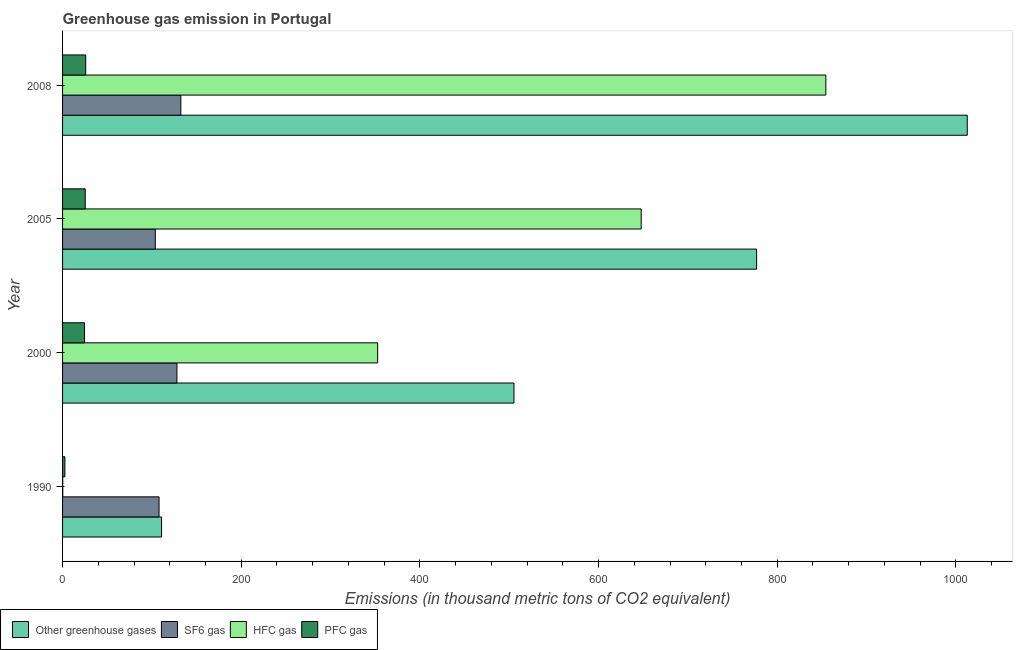How many different coloured bars are there?
Offer a very short reply. 4. Are the number of bars per tick equal to the number of legend labels?
Keep it short and to the point. Yes. Are the number of bars on each tick of the Y-axis equal?
Give a very brief answer. Yes. In how many cases, is the number of bars for a given year not equal to the number of legend labels?
Keep it short and to the point. 0. What is the emission of pfc gas in 1990?
Make the answer very short. 2.6. Across all years, what is the maximum emission of pfc gas?
Provide a short and direct response. 25.9. Across all years, what is the minimum emission of sf6 gas?
Offer a very short reply. 103.8. In which year was the emission of hfc gas minimum?
Your answer should be very brief. 1990. What is the total emission of greenhouse gases in the graph?
Your answer should be compact. 2405.7. What is the difference between the emission of pfc gas in 2005 and that in 2008?
Make the answer very short. -0.5. What is the difference between the emission of sf6 gas in 2000 and the emission of hfc gas in 2008?
Your answer should be compact. -726.4. What is the average emission of hfc gas per year?
Provide a succinct answer. 463.75. In the year 2008, what is the difference between the emission of greenhouse gases and emission of hfc gas?
Provide a succinct answer. 158.3. In how many years, is the emission of sf6 gas greater than 240 thousand metric tons?
Give a very brief answer. 0. What is the ratio of the emission of greenhouse gases in 2000 to that in 2005?
Your answer should be very brief. 0.65. Is the emission of hfc gas in 2000 less than that in 2008?
Offer a terse response. Yes. Is the difference between the emission of greenhouse gases in 1990 and 2005 greater than the difference between the emission of sf6 gas in 1990 and 2005?
Provide a succinct answer. No. What is the difference between the highest and the second highest emission of hfc gas?
Give a very brief answer. 206.7. What is the difference between the highest and the lowest emission of hfc gas?
Your answer should be very brief. 854.2. In how many years, is the emission of sf6 gas greater than the average emission of sf6 gas taken over all years?
Your answer should be compact. 2. Is the sum of the emission of greenhouse gases in 1990 and 2005 greater than the maximum emission of sf6 gas across all years?
Your answer should be very brief. Yes. Is it the case that in every year, the sum of the emission of greenhouse gases and emission of sf6 gas is greater than the sum of emission of hfc gas and emission of pfc gas?
Give a very brief answer. Yes. What does the 2nd bar from the top in 2005 represents?
Keep it short and to the point. HFC gas. What does the 3rd bar from the bottom in 2000 represents?
Offer a very short reply. HFC gas. Is it the case that in every year, the sum of the emission of greenhouse gases and emission of sf6 gas is greater than the emission of hfc gas?
Keep it short and to the point. Yes. Are all the bars in the graph horizontal?
Ensure brevity in your answer.  Yes. How many years are there in the graph?
Offer a very short reply. 4. Are the values on the major ticks of X-axis written in scientific E-notation?
Give a very brief answer. No. Does the graph contain any zero values?
Make the answer very short. No. Does the graph contain grids?
Ensure brevity in your answer.  No. How many legend labels are there?
Give a very brief answer. 4. How are the legend labels stacked?
Make the answer very short. Horizontal. What is the title of the graph?
Offer a very short reply. Greenhouse gas emission in Portugal. Does "Subsidies and Transfers" appear as one of the legend labels in the graph?
Your answer should be compact. No. What is the label or title of the X-axis?
Offer a very short reply. Emissions (in thousand metric tons of CO2 equivalent). What is the label or title of the Y-axis?
Provide a short and direct response. Year. What is the Emissions (in thousand metric tons of CO2 equivalent) of Other greenhouse gases in 1990?
Offer a terse response. 110.8. What is the Emissions (in thousand metric tons of CO2 equivalent) in SF6 gas in 1990?
Ensure brevity in your answer.  108. What is the Emissions (in thousand metric tons of CO2 equivalent) of HFC gas in 1990?
Your response must be concise. 0.2. What is the Emissions (in thousand metric tons of CO2 equivalent) in Other greenhouse gases in 2000?
Your response must be concise. 505.3. What is the Emissions (in thousand metric tons of CO2 equivalent) of SF6 gas in 2000?
Provide a succinct answer. 128. What is the Emissions (in thousand metric tons of CO2 equivalent) of HFC gas in 2000?
Make the answer very short. 352.7. What is the Emissions (in thousand metric tons of CO2 equivalent) in PFC gas in 2000?
Keep it short and to the point. 24.6. What is the Emissions (in thousand metric tons of CO2 equivalent) in Other greenhouse gases in 2005?
Keep it short and to the point. 776.9. What is the Emissions (in thousand metric tons of CO2 equivalent) of SF6 gas in 2005?
Your answer should be very brief. 103.8. What is the Emissions (in thousand metric tons of CO2 equivalent) of HFC gas in 2005?
Offer a terse response. 647.7. What is the Emissions (in thousand metric tons of CO2 equivalent) of PFC gas in 2005?
Your response must be concise. 25.4. What is the Emissions (in thousand metric tons of CO2 equivalent) in Other greenhouse gases in 2008?
Give a very brief answer. 1012.7. What is the Emissions (in thousand metric tons of CO2 equivalent) of SF6 gas in 2008?
Give a very brief answer. 132.4. What is the Emissions (in thousand metric tons of CO2 equivalent) in HFC gas in 2008?
Offer a terse response. 854.4. What is the Emissions (in thousand metric tons of CO2 equivalent) in PFC gas in 2008?
Give a very brief answer. 25.9. Across all years, what is the maximum Emissions (in thousand metric tons of CO2 equivalent) in Other greenhouse gases?
Your answer should be compact. 1012.7. Across all years, what is the maximum Emissions (in thousand metric tons of CO2 equivalent) in SF6 gas?
Your response must be concise. 132.4. Across all years, what is the maximum Emissions (in thousand metric tons of CO2 equivalent) in HFC gas?
Your answer should be compact. 854.4. Across all years, what is the maximum Emissions (in thousand metric tons of CO2 equivalent) of PFC gas?
Your answer should be very brief. 25.9. Across all years, what is the minimum Emissions (in thousand metric tons of CO2 equivalent) of Other greenhouse gases?
Your answer should be compact. 110.8. Across all years, what is the minimum Emissions (in thousand metric tons of CO2 equivalent) in SF6 gas?
Offer a terse response. 103.8. Across all years, what is the minimum Emissions (in thousand metric tons of CO2 equivalent) of PFC gas?
Ensure brevity in your answer.  2.6. What is the total Emissions (in thousand metric tons of CO2 equivalent) of Other greenhouse gases in the graph?
Your answer should be very brief. 2405.7. What is the total Emissions (in thousand metric tons of CO2 equivalent) in SF6 gas in the graph?
Provide a short and direct response. 472.2. What is the total Emissions (in thousand metric tons of CO2 equivalent) of HFC gas in the graph?
Keep it short and to the point. 1855. What is the total Emissions (in thousand metric tons of CO2 equivalent) in PFC gas in the graph?
Provide a short and direct response. 78.5. What is the difference between the Emissions (in thousand metric tons of CO2 equivalent) in Other greenhouse gases in 1990 and that in 2000?
Ensure brevity in your answer.  -394.5. What is the difference between the Emissions (in thousand metric tons of CO2 equivalent) in SF6 gas in 1990 and that in 2000?
Your answer should be compact. -20. What is the difference between the Emissions (in thousand metric tons of CO2 equivalent) of HFC gas in 1990 and that in 2000?
Keep it short and to the point. -352.5. What is the difference between the Emissions (in thousand metric tons of CO2 equivalent) of PFC gas in 1990 and that in 2000?
Offer a very short reply. -22. What is the difference between the Emissions (in thousand metric tons of CO2 equivalent) in Other greenhouse gases in 1990 and that in 2005?
Provide a short and direct response. -666.1. What is the difference between the Emissions (in thousand metric tons of CO2 equivalent) of HFC gas in 1990 and that in 2005?
Your answer should be compact. -647.5. What is the difference between the Emissions (in thousand metric tons of CO2 equivalent) of PFC gas in 1990 and that in 2005?
Give a very brief answer. -22.8. What is the difference between the Emissions (in thousand metric tons of CO2 equivalent) in Other greenhouse gases in 1990 and that in 2008?
Keep it short and to the point. -901.9. What is the difference between the Emissions (in thousand metric tons of CO2 equivalent) of SF6 gas in 1990 and that in 2008?
Your answer should be very brief. -24.4. What is the difference between the Emissions (in thousand metric tons of CO2 equivalent) in HFC gas in 1990 and that in 2008?
Keep it short and to the point. -854.2. What is the difference between the Emissions (in thousand metric tons of CO2 equivalent) of PFC gas in 1990 and that in 2008?
Make the answer very short. -23.3. What is the difference between the Emissions (in thousand metric tons of CO2 equivalent) of Other greenhouse gases in 2000 and that in 2005?
Provide a short and direct response. -271.6. What is the difference between the Emissions (in thousand metric tons of CO2 equivalent) of SF6 gas in 2000 and that in 2005?
Offer a terse response. 24.2. What is the difference between the Emissions (in thousand metric tons of CO2 equivalent) of HFC gas in 2000 and that in 2005?
Keep it short and to the point. -295. What is the difference between the Emissions (in thousand metric tons of CO2 equivalent) in Other greenhouse gases in 2000 and that in 2008?
Your answer should be compact. -507.4. What is the difference between the Emissions (in thousand metric tons of CO2 equivalent) in HFC gas in 2000 and that in 2008?
Provide a succinct answer. -501.7. What is the difference between the Emissions (in thousand metric tons of CO2 equivalent) in PFC gas in 2000 and that in 2008?
Give a very brief answer. -1.3. What is the difference between the Emissions (in thousand metric tons of CO2 equivalent) in Other greenhouse gases in 2005 and that in 2008?
Your answer should be very brief. -235.8. What is the difference between the Emissions (in thousand metric tons of CO2 equivalent) of SF6 gas in 2005 and that in 2008?
Your answer should be very brief. -28.6. What is the difference between the Emissions (in thousand metric tons of CO2 equivalent) of HFC gas in 2005 and that in 2008?
Your answer should be very brief. -206.7. What is the difference between the Emissions (in thousand metric tons of CO2 equivalent) in PFC gas in 2005 and that in 2008?
Offer a very short reply. -0.5. What is the difference between the Emissions (in thousand metric tons of CO2 equivalent) in Other greenhouse gases in 1990 and the Emissions (in thousand metric tons of CO2 equivalent) in SF6 gas in 2000?
Offer a terse response. -17.2. What is the difference between the Emissions (in thousand metric tons of CO2 equivalent) of Other greenhouse gases in 1990 and the Emissions (in thousand metric tons of CO2 equivalent) of HFC gas in 2000?
Make the answer very short. -241.9. What is the difference between the Emissions (in thousand metric tons of CO2 equivalent) of Other greenhouse gases in 1990 and the Emissions (in thousand metric tons of CO2 equivalent) of PFC gas in 2000?
Your response must be concise. 86.2. What is the difference between the Emissions (in thousand metric tons of CO2 equivalent) of SF6 gas in 1990 and the Emissions (in thousand metric tons of CO2 equivalent) of HFC gas in 2000?
Offer a very short reply. -244.7. What is the difference between the Emissions (in thousand metric tons of CO2 equivalent) in SF6 gas in 1990 and the Emissions (in thousand metric tons of CO2 equivalent) in PFC gas in 2000?
Ensure brevity in your answer.  83.4. What is the difference between the Emissions (in thousand metric tons of CO2 equivalent) in HFC gas in 1990 and the Emissions (in thousand metric tons of CO2 equivalent) in PFC gas in 2000?
Offer a terse response. -24.4. What is the difference between the Emissions (in thousand metric tons of CO2 equivalent) of Other greenhouse gases in 1990 and the Emissions (in thousand metric tons of CO2 equivalent) of SF6 gas in 2005?
Offer a very short reply. 7. What is the difference between the Emissions (in thousand metric tons of CO2 equivalent) of Other greenhouse gases in 1990 and the Emissions (in thousand metric tons of CO2 equivalent) of HFC gas in 2005?
Ensure brevity in your answer.  -536.9. What is the difference between the Emissions (in thousand metric tons of CO2 equivalent) in Other greenhouse gases in 1990 and the Emissions (in thousand metric tons of CO2 equivalent) in PFC gas in 2005?
Your response must be concise. 85.4. What is the difference between the Emissions (in thousand metric tons of CO2 equivalent) in SF6 gas in 1990 and the Emissions (in thousand metric tons of CO2 equivalent) in HFC gas in 2005?
Give a very brief answer. -539.7. What is the difference between the Emissions (in thousand metric tons of CO2 equivalent) of SF6 gas in 1990 and the Emissions (in thousand metric tons of CO2 equivalent) of PFC gas in 2005?
Provide a succinct answer. 82.6. What is the difference between the Emissions (in thousand metric tons of CO2 equivalent) in HFC gas in 1990 and the Emissions (in thousand metric tons of CO2 equivalent) in PFC gas in 2005?
Your answer should be compact. -25.2. What is the difference between the Emissions (in thousand metric tons of CO2 equivalent) in Other greenhouse gases in 1990 and the Emissions (in thousand metric tons of CO2 equivalent) in SF6 gas in 2008?
Provide a short and direct response. -21.6. What is the difference between the Emissions (in thousand metric tons of CO2 equivalent) of Other greenhouse gases in 1990 and the Emissions (in thousand metric tons of CO2 equivalent) of HFC gas in 2008?
Your answer should be very brief. -743.6. What is the difference between the Emissions (in thousand metric tons of CO2 equivalent) of Other greenhouse gases in 1990 and the Emissions (in thousand metric tons of CO2 equivalent) of PFC gas in 2008?
Your answer should be very brief. 84.9. What is the difference between the Emissions (in thousand metric tons of CO2 equivalent) in SF6 gas in 1990 and the Emissions (in thousand metric tons of CO2 equivalent) in HFC gas in 2008?
Provide a short and direct response. -746.4. What is the difference between the Emissions (in thousand metric tons of CO2 equivalent) in SF6 gas in 1990 and the Emissions (in thousand metric tons of CO2 equivalent) in PFC gas in 2008?
Keep it short and to the point. 82.1. What is the difference between the Emissions (in thousand metric tons of CO2 equivalent) of HFC gas in 1990 and the Emissions (in thousand metric tons of CO2 equivalent) of PFC gas in 2008?
Offer a very short reply. -25.7. What is the difference between the Emissions (in thousand metric tons of CO2 equivalent) of Other greenhouse gases in 2000 and the Emissions (in thousand metric tons of CO2 equivalent) of SF6 gas in 2005?
Provide a succinct answer. 401.5. What is the difference between the Emissions (in thousand metric tons of CO2 equivalent) in Other greenhouse gases in 2000 and the Emissions (in thousand metric tons of CO2 equivalent) in HFC gas in 2005?
Provide a succinct answer. -142.4. What is the difference between the Emissions (in thousand metric tons of CO2 equivalent) of Other greenhouse gases in 2000 and the Emissions (in thousand metric tons of CO2 equivalent) of PFC gas in 2005?
Offer a terse response. 479.9. What is the difference between the Emissions (in thousand metric tons of CO2 equivalent) of SF6 gas in 2000 and the Emissions (in thousand metric tons of CO2 equivalent) of HFC gas in 2005?
Offer a very short reply. -519.7. What is the difference between the Emissions (in thousand metric tons of CO2 equivalent) in SF6 gas in 2000 and the Emissions (in thousand metric tons of CO2 equivalent) in PFC gas in 2005?
Keep it short and to the point. 102.6. What is the difference between the Emissions (in thousand metric tons of CO2 equivalent) in HFC gas in 2000 and the Emissions (in thousand metric tons of CO2 equivalent) in PFC gas in 2005?
Provide a short and direct response. 327.3. What is the difference between the Emissions (in thousand metric tons of CO2 equivalent) of Other greenhouse gases in 2000 and the Emissions (in thousand metric tons of CO2 equivalent) of SF6 gas in 2008?
Offer a terse response. 372.9. What is the difference between the Emissions (in thousand metric tons of CO2 equivalent) in Other greenhouse gases in 2000 and the Emissions (in thousand metric tons of CO2 equivalent) in HFC gas in 2008?
Provide a succinct answer. -349.1. What is the difference between the Emissions (in thousand metric tons of CO2 equivalent) of Other greenhouse gases in 2000 and the Emissions (in thousand metric tons of CO2 equivalent) of PFC gas in 2008?
Your answer should be compact. 479.4. What is the difference between the Emissions (in thousand metric tons of CO2 equivalent) of SF6 gas in 2000 and the Emissions (in thousand metric tons of CO2 equivalent) of HFC gas in 2008?
Keep it short and to the point. -726.4. What is the difference between the Emissions (in thousand metric tons of CO2 equivalent) of SF6 gas in 2000 and the Emissions (in thousand metric tons of CO2 equivalent) of PFC gas in 2008?
Your answer should be very brief. 102.1. What is the difference between the Emissions (in thousand metric tons of CO2 equivalent) in HFC gas in 2000 and the Emissions (in thousand metric tons of CO2 equivalent) in PFC gas in 2008?
Offer a very short reply. 326.8. What is the difference between the Emissions (in thousand metric tons of CO2 equivalent) of Other greenhouse gases in 2005 and the Emissions (in thousand metric tons of CO2 equivalent) of SF6 gas in 2008?
Your answer should be compact. 644.5. What is the difference between the Emissions (in thousand metric tons of CO2 equivalent) in Other greenhouse gases in 2005 and the Emissions (in thousand metric tons of CO2 equivalent) in HFC gas in 2008?
Your answer should be compact. -77.5. What is the difference between the Emissions (in thousand metric tons of CO2 equivalent) in Other greenhouse gases in 2005 and the Emissions (in thousand metric tons of CO2 equivalent) in PFC gas in 2008?
Give a very brief answer. 751. What is the difference between the Emissions (in thousand metric tons of CO2 equivalent) of SF6 gas in 2005 and the Emissions (in thousand metric tons of CO2 equivalent) of HFC gas in 2008?
Keep it short and to the point. -750.6. What is the difference between the Emissions (in thousand metric tons of CO2 equivalent) of SF6 gas in 2005 and the Emissions (in thousand metric tons of CO2 equivalent) of PFC gas in 2008?
Give a very brief answer. 77.9. What is the difference between the Emissions (in thousand metric tons of CO2 equivalent) of HFC gas in 2005 and the Emissions (in thousand metric tons of CO2 equivalent) of PFC gas in 2008?
Your response must be concise. 621.8. What is the average Emissions (in thousand metric tons of CO2 equivalent) in Other greenhouse gases per year?
Your answer should be compact. 601.42. What is the average Emissions (in thousand metric tons of CO2 equivalent) of SF6 gas per year?
Offer a very short reply. 118.05. What is the average Emissions (in thousand metric tons of CO2 equivalent) in HFC gas per year?
Give a very brief answer. 463.75. What is the average Emissions (in thousand metric tons of CO2 equivalent) in PFC gas per year?
Provide a succinct answer. 19.62. In the year 1990, what is the difference between the Emissions (in thousand metric tons of CO2 equivalent) of Other greenhouse gases and Emissions (in thousand metric tons of CO2 equivalent) of SF6 gas?
Offer a very short reply. 2.8. In the year 1990, what is the difference between the Emissions (in thousand metric tons of CO2 equivalent) of Other greenhouse gases and Emissions (in thousand metric tons of CO2 equivalent) of HFC gas?
Offer a very short reply. 110.6. In the year 1990, what is the difference between the Emissions (in thousand metric tons of CO2 equivalent) of Other greenhouse gases and Emissions (in thousand metric tons of CO2 equivalent) of PFC gas?
Provide a succinct answer. 108.2. In the year 1990, what is the difference between the Emissions (in thousand metric tons of CO2 equivalent) in SF6 gas and Emissions (in thousand metric tons of CO2 equivalent) in HFC gas?
Keep it short and to the point. 107.8. In the year 1990, what is the difference between the Emissions (in thousand metric tons of CO2 equivalent) in SF6 gas and Emissions (in thousand metric tons of CO2 equivalent) in PFC gas?
Provide a succinct answer. 105.4. In the year 1990, what is the difference between the Emissions (in thousand metric tons of CO2 equivalent) in HFC gas and Emissions (in thousand metric tons of CO2 equivalent) in PFC gas?
Offer a very short reply. -2.4. In the year 2000, what is the difference between the Emissions (in thousand metric tons of CO2 equivalent) of Other greenhouse gases and Emissions (in thousand metric tons of CO2 equivalent) of SF6 gas?
Your answer should be very brief. 377.3. In the year 2000, what is the difference between the Emissions (in thousand metric tons of CO2 equivalent) in Other greenhouse gases and Emissions (in thousand metric tons of CO2 equivalent) in HFC gas?
Your answer should be very brief. 152.6. In the year 2000, what is the difference between the Emissions (in thousand metric tons of CO2 equivalent) of Other greenhouse gases and Emissions (in thousand metric tons of CO2 equivalent) of PFC gas?
Ensure brevity in your answer.  480.7. In the year 2000, what is the difference between the Emissions (in thousand metric tons of CO2 equivalent) in SF6 gas and Emissions (in thousand metric tons of CO2 equivalent) in HFC gas?
Give a very brief answer. -224.7. In the year 2000, what is the difference between the Emissions (in thousand metric tons of CO2 equivalent) of SF6 gas and Emissions (in thousand metric tons of CO2 equivalent) of PFC gas?
Make the answer very short. 103.4. In the year 2000, what is the difference between the Emissions (in thousand metric tons of CO2 equivalent) in HFC gas and Emissions (in thousand metric tons of CO2 equivalent) in PFC gas?
Keep it short and to the point. 328.1. In the year 2005, what is the difference between the Emissions (in thousand metric tons of CO2 equivalent) in Other greenhouse gases and Emissions (in thousand metric tons of CO2 equivalent) in SF6 gas?
Keep it short and to the point. 673.1. In the year 2005, what is the difference between the Emissions (in thousand metric tons of CO2 equivalent) of Other greenhouse gases and Emissions (in thousand metric tons of CO2 equivalent) of HFC gas?
Your answer should be very brief. 129.2. In the year 2005, what is the difference between the Emissions (in thousand metric tons of CO2 equivalent) in Other greenhouse gases and Emissions (in thousand metric tons of CO2 equivalent) in PFC gas?
Make the answer very short. 751.5. In the year 2005, what is the difference between the Emissions (in thousand metric tons of CO2 equivalent) in SF6 gas and Emissions (in thousand metric tons of CO2 equivalent) in HFC gas?
Provide a succinct answer. -543.9. In the year 2005, what is the difference between the Emissions (in thousand metric tons of CO2 equivalent) of SF6 gas and Emissions (in thousand metric tons of CO2 equivalent) of PFC gas?
Provide a succinct answer. 78.4. In the year 2005, what is the difference between the Emissions (in thousand metric tons of CO2 equivalent) in HFC gas and Emissions (in thousand metric tons of CO2 equivalent) in PFC gas?
Offer a very short reply. 622.3. In the year 2008, what is the difference between the Emissions (in thousand metric tons of CO2 equivalent) in Other greenhouse gases and Emissions (in thousand metric tons of CO2 equivalent) in SF6 gas?
Provide a short and direct response. 880.3. In the year 2008, what is the difference between the Emissions (in thousand metric tons of CO2 equivalent) of Other greenhouse gases and Emissions (in thousand metric tons of CO2 equivalent) of HFC gas?
Provide a short and direct response. 158.3. In the year 2008, what is the difference between the Emissions (in thousand metric tons of CO2 equivalent) in Other greenhouse gases and Emissions (in thousand metric tons of CO2 equivalent) in PFC gas?
Your answer should be very brief. 986.8. In the year 2008, what is the difference between the Emissions (in thousand metric tons of CO2 equivalent) in SF6 gas and Emissions (in thousand metric tons of CO2 equivalent) in HFC gas?
Your answer should be compact. -722. In the year 2008, what is the difference between the Emissions (in thousand metric tons of CO2 equivalent) in SF6 gas and Emissions (in thousand metric tons of CO2 equivalent) in PFC gas?
Your answer should be very brief. 106.5. In the year 2008, what is the difference between the Emissions (in thousand metric tons of CO2 equivalent) of HFC gas and Emissions (in thousand metric tons of CO2 equivalent) of PFC gas?
Offer a very short reply. 828.5. What is the ratio of the Emissions (in thousand metric tons of CO2 equivalent) of Other greenhouse gases in 1990 to that in 2000?
Give a very brief answer. 0.22. What is the ratio of the Emissions (in thousand metric tons of CO2 equivalent) of SF6 gas in 1990 to that in 2000?
Your answer should be very brief. 0.84. What is the ratio of the Emissions (in thousand metric tons of CO2 equivalent) of HFC gas in 1990 to that in 2000?
Provide a succinct answer. 0. What is the ratio of the Emissions (in thousand metric tons of CO2 equivalent) of PFC gas in 1990 to that in 2000?
Offer a very short reply. 0.11. What is the ratio of the Emissions (in thousand metric tons of CO2 equivalent) in Other greenhouse gases in 1990 to that in 2005?
Your answer should be very brief. 0.14. What is the ratio of the Emissions (in thousand metric tons of CO2 equivalent) in SF6 gas in 1990 to that in 2005?
Your answer should be compact. 1.04. What is the ratio of the Emissions (in thousand metric tons of CO2 equivalent) of HFC gas in 1990 to that in 2005?
Keep it short and to the point. 0. What is the ratio of the Emissions (in thousand metric tons of CO2 equivalent) in PFC gas in 1990 to that in 2005?
Your response must be concise. 0.1. What is the ratio of the Emissions (in thousand metric tons of CO2 equivalent) of Other greenhouse gases in 1990 to that in 2008?
Ensure brevity in your answer.  0.11. What is the ratio of the Emissions (in thousand metric tons of CO2 equivalent) in SF6 gas in 1990 to that in 2008?
Keep it short and to the point. 0.82. What is the ratio of the Emissions (in thousand metric tons of CO2 equivalent) of PFC gas in 1990 to that in 2008?
Ensure brevity in your answer.  0.1. What is the ratio of the Emissions (in thousand metric tons of CO2 equivalent) in Other greenhouse gases in 2000 to that in 2005?
Provide a succinct answer. 0.65. What is the ratio of the Emissions (in thousand metric tons of CO2 equivalent) of SF6 gas in 2000 to that in 2005?
Provide a succinct answer. 1.23. What is the ratio of the Emissions (in thousand metric tons of CO2 equivalent) in HFC gas in 2000 to that in 2005?
Ensure brevity in your answer.  0.54. What is the ratio of the Emissions (in thousand metric tons of CO2 equivalent) in PFC gas in 2000 to that in 2005?
Provide a succinct answer. 0.97. What is the ratio of the Emissions (in thousand metric tons of CO2 equivalent) in Other greenhouse gases in 2000 to that in 2008?
Offer a terse response. 0.5. What is the ratio of the Emissions (in thousand metric tons of CO2 equivalent) in SF6 gas in 2000 to that in 2008?
Your response must be concise. 0.97. What is the ratio of the Emissions (in thousand metric tons of CO2 equivalent) in HFC gas in 2000 to that in 2008?
Give a very brief answer. 0.41. What is the ratio of the Emissions (in thousand metric tons of CO2 equivalent) of PFC gas in 2000 to that in 2008?
Offer a terse response. 0.95. What is the ratio of the Emissions (in thousand metric tons of CO2 equivalent) of Other greenhouse gases in 2005 to that in 2008?
Your answer should be compact. 0.77. What is the ratio of the Emissions (in thousand metric tons of CO2 equivalent) of SF6 gas in 2005 to that in 2008?
Your answer should be compact. 0.78. What is the ratio of the Emissions (in thousand metric tons of CO2 equivalent) in HFC gas in 2005 to that in 2008?
Make the answer very short. 0.76. What is the ratio of the Emissions (in thousand metric tons of CO2 equivalent) of PFC gas in 2005 to that in 2008?
Provide a succinct answer. 0.98. What is the difference between the highest and the second highest Emissions (in thousand metric tons of CO2 equivalent) in Other greenhouse gases?
Keep it short and to the point. 235.8. What is the difference between the highest and the second highest Emissions (in thousand metric tons of CO2 equivalent) in SF6 gas?
Give a very brief answer. 4.4. What is the difference between the highest and the second highest Emissions (in thousand metric tons of CO2 equivalent) of HFC gas?
Provide a short and direct response. 206.7. What is the difference between the highest and the lowest Emissions (in thousand metric tons of CO2 equivalent) of Other greenhouse gases?
Ensure brevity in your answer.  901.9. What is the difference between the highest and the lowest Emissions (in thousand metric tons of CO2 equivalent) of SF6 gas?
Provide a succinct answer. 28.6. What is the difference between the highest and the lowest Emissions (in thousand metric tons of CO2 equivalent) of HFC gas?
Your answer should be very brief. 854.2. What is the difference between the highest and the lowest Emissions (in thousand metric tons of CO2 equivalent) in PFC gas?
Your response must be concise. 23.3. 